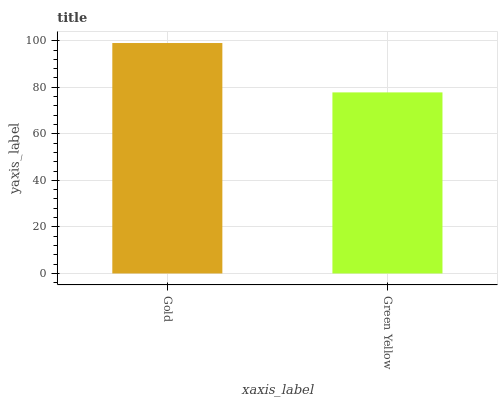Is Green Yellow the minimum?
Answer yes or no. Yes. Is Gold the maximum?
Answer yes or no. Yes. Is Green Yellow the maximum?
Answer yes or no. No. Is Gold greater than Green Yellow?
Answer yes or no. Yes. Is Green Yellow less than Gold?
Answer yes or no. Yes. Is Green Yellow greater than Gold?
Answer yes or no. No. Is Gold less than Green Yellow?
Answer yes or no. No. Is Gold the high median?
Answer yes or no. Yes. Is Green Yellow the low median?
Answer yes or no. Yes. Is Green Yellow the high median?
Answer yes or no. No. Is Gold the low median?
Answer yes or no. No. 